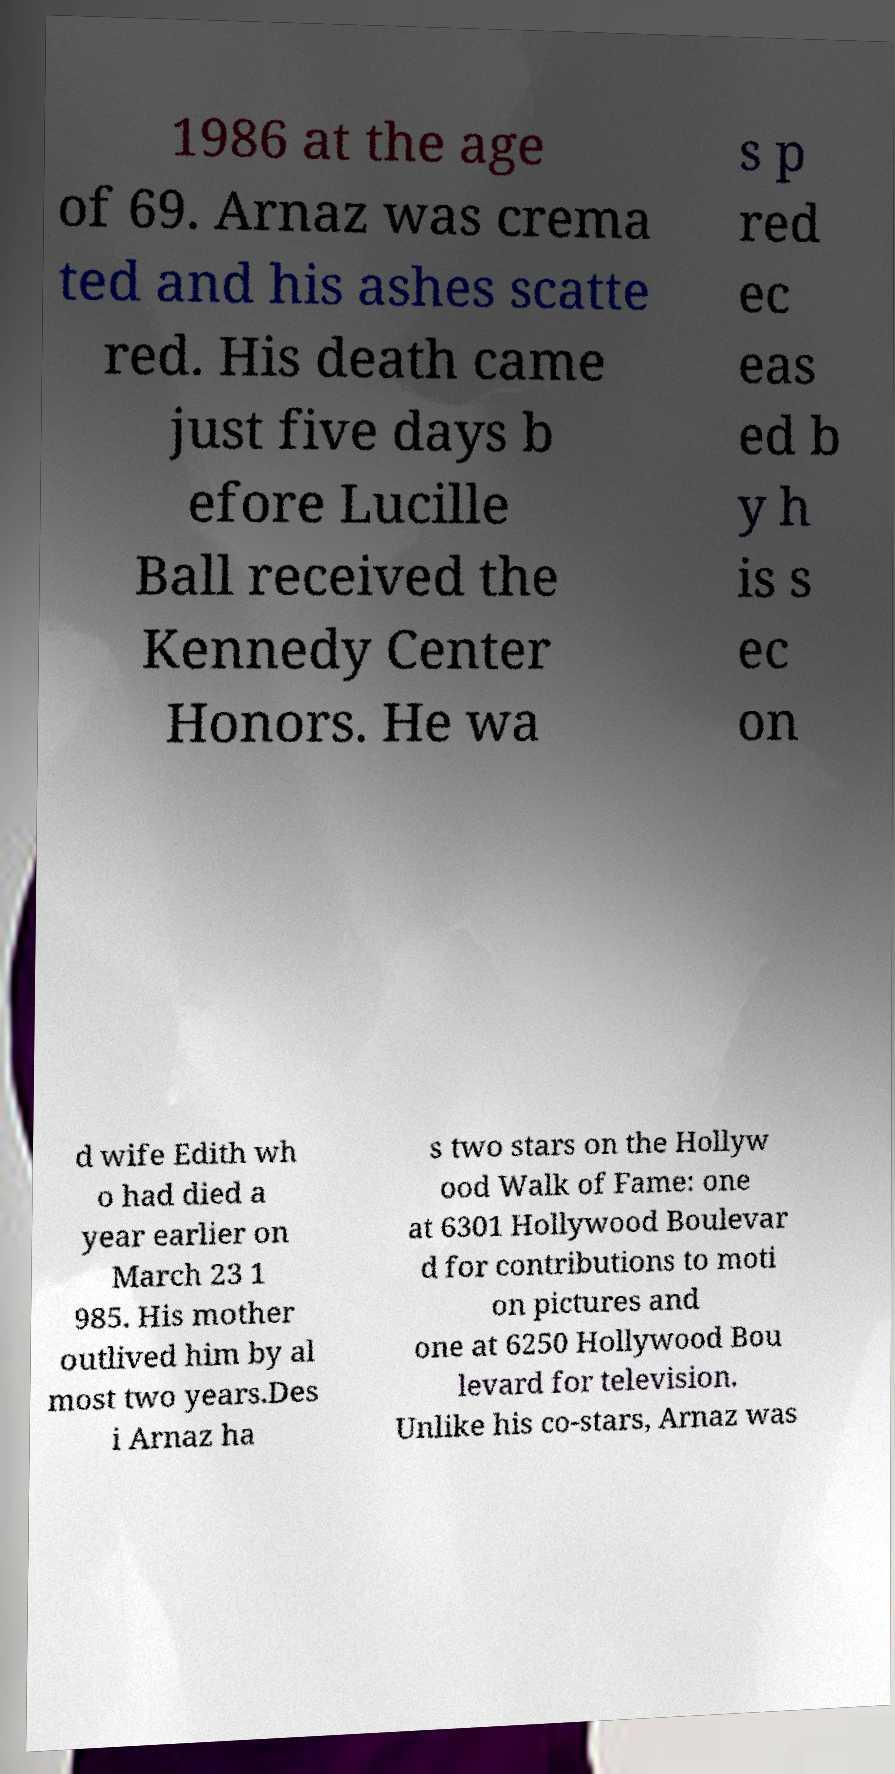Could you extract and type out the text from this image? 1986 at the age of 69. Arnaz was crema ted and his ashes scatte red. His death came just five days b efore Lucille Ball received the Kennedy Center Honors. He wa s p red ec eas ed b y h is s ec on d wife Edith wh o had died a year earlier on March 23 1 985. His mother outlived him by al most two years.Des i Arnaz ha s two stars on the Hollyw ood Walk of Fame: one at 6301 Hollywood Boulevar d for contributions to moti on pictures and one at 6250 Hollywood Bou levard for television. Unlike his co-stars, Arnaz was 